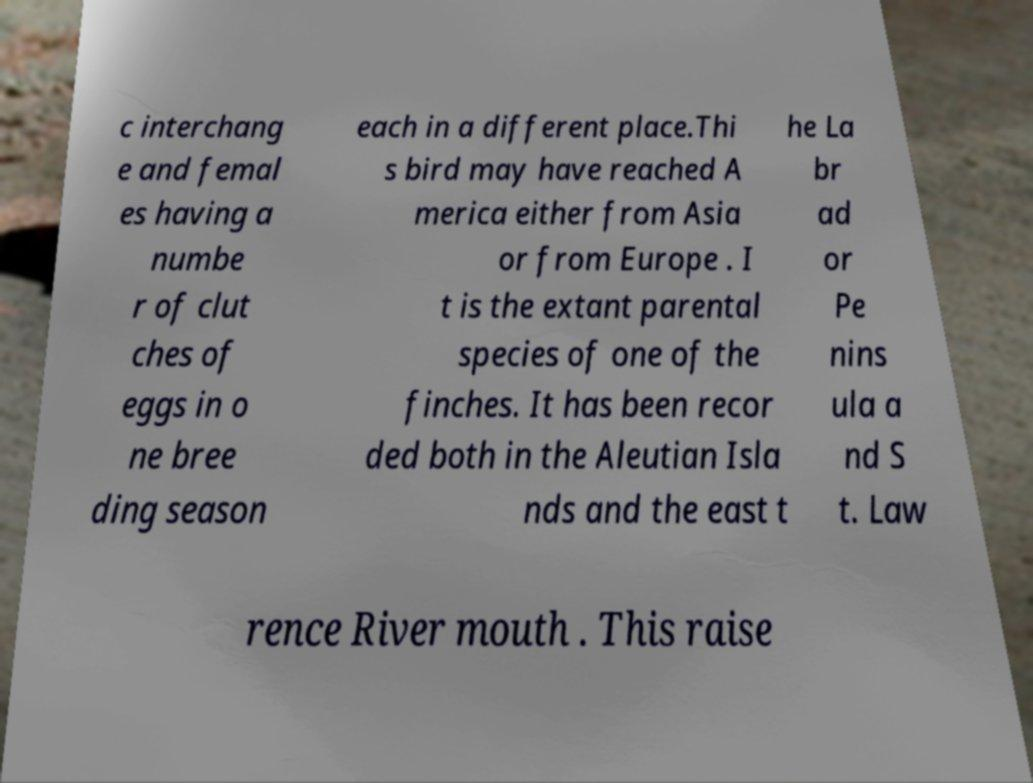Please identify and transcribe the text found in this image. c interchang e and femal es having a numbe r of clut ches of eggs in o ne bree ding season each in a different place.Thi s bird may have reached A merica either from Asia or from Europe . I t is the extant parental species of one of the finches. It has been recor ded both in the Aleutian Isla nds and the east t he La br ad or Pe nins ula a nd S t. Law rence River mouth . This raise 